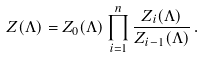Convert formula to latex. <formula><loc_0><loc_0><loc_500><loc_500>Z ( \Lambda ) = Z _ { 0 } ( \Lambda ) \prod _ { i = 1 } ^ { n } \frac { Z _ { i } ( \Lambda ) } { Z _ { i - 1 } ( \Lambda ) } \, .</formula> 